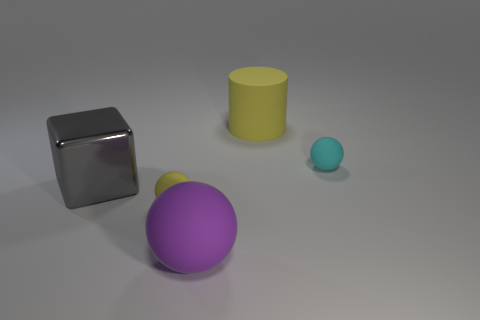Is the number of big gray metallic things in front of the shiny cube the same as the number of tiny yellow objects that are in front of the large purple rubber object? yes 